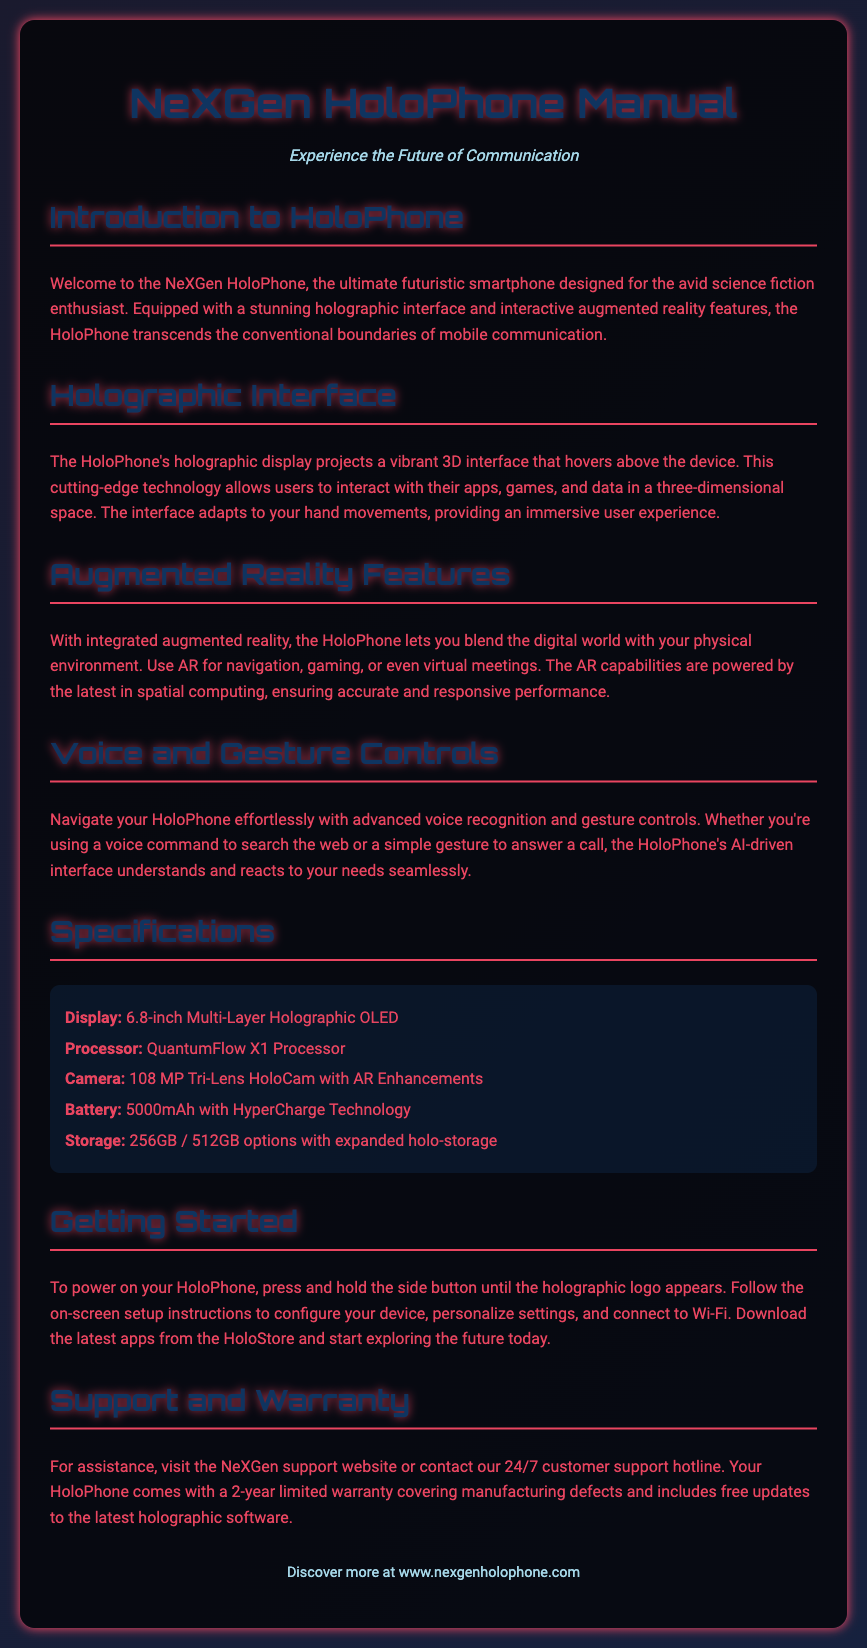What is the name of the smartphone? The smartphone is referred to as the NeXGen HoloPhone in the document.
Answer: NeXGen HoloPhone What type of display does the HoloPhone have? The document specifies that the display type is a Multi-Layer Holographic OLED.
Answer: Multi-Layer Holographic OLED What is the camera resolution of the HoloPhone? The document states that the camera resolution is 108 MP.
Answer: 108 MP How long is the warranty for the HoloPhone? According to the document, the warranty is a 2-year limited warranty.
Answer: 2 years What processor does the HoloPhone use? The processor mentioned in the document is the QuantumFlow X1 Processor.
Answer: QuantumFlow X1 Processor Which technology powers the HoloPhone's augmented reality features? The document indicates that the AR capabilities are powered by the latest in spatial computing.
Answer: Spatial computing What action should you take to power on the HoloPhone? The document instructs users to press and hold the side button until the holographic logo appears to power on the device.
Answer: Press and hold the side button What is required to set up the HoloPhone? The document suggests following on-screen setup instructions to configure the device.
Answer: Follow on-screen instructions What support options are available for HoloPhone users? The document mentions visiting the NeXGen support website or contacting the 24/7 customer support hotline for assistance.
Answer: NeXGen support website or 24/7 customer support hotline 